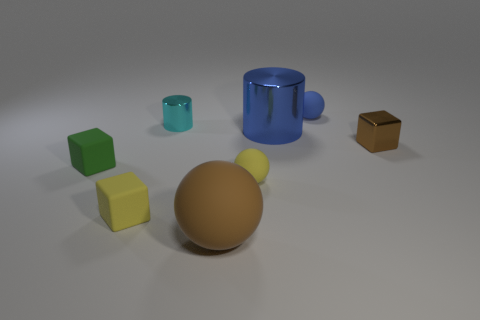There is a thing behind the small cyan object; is its color the same as the cylinder in front of the small cylinder?
Provide a short and direct response. Yes. What color is the metal object that is both in front of the small cyan metallic cylinder and to the left of the tiny brown thing?
Ensure brevity in your answer.  Blue. Do the blue thing behind the cyan thing and the small cyan shiny thing have the same size?
Your answer should be very brief. Yes. Is the number of tiny cylinders that are in front of the blue sphere greater than the number of tiny gray metal blocks?
Provide a succinct answer. Yes. Does the large blue thing have the same shape as the brown rubber thing?
Your answer should be compact. No. The blue metal thing is what size?
Provide a succinct answer. Large. Are there more rubber objects behind the brown shiny block than small green matte cubes right of the big brown rubber sphere?
Offer a very short reply. Yes. There is a big blue shiny cylinder; are there any large blue metallic objects right of it?
Make the answer very short. No. Are there any blue shiny cylinders that have the same size as the green matte object?
Make the answer very short. No. What color is the other cylinder that is the same material as the blue cylinder?
Your answer should be compact. Cyan. 